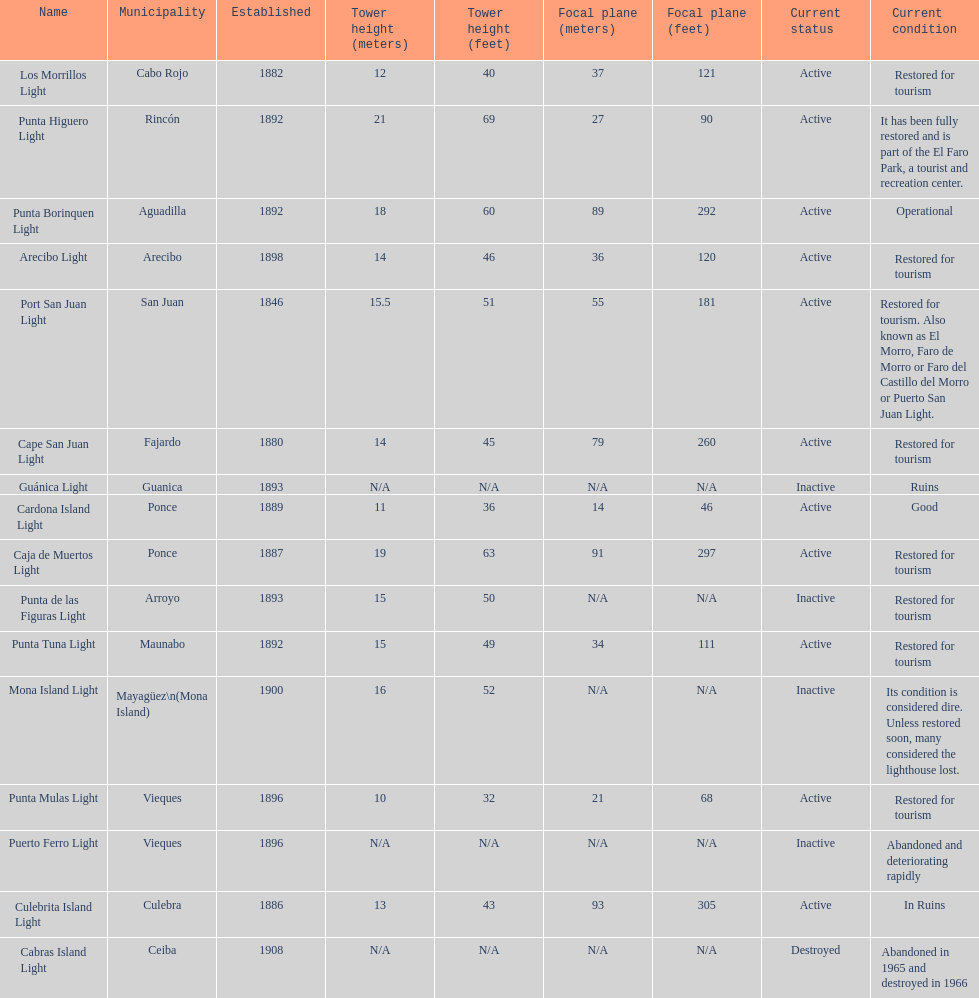Names of municipalities established before 1880 San Juan. Could you parse the entire table as a dict? {'header': ['Name', 'Municipality', 'Established', 'Tower height (meters)', 'Tower height (feet)', 'Focal plane (meters)', 'Focal plane (feet)', 'Current status', 'Current condition'], 'rows': [['Los Morrillos Light', 'Cabo Rojo', '1882', '12', '40', '37', '121', 'Active', 'Restored for tourism'], ['Punta Higuero Light', 'Rincón', '1892', '21', '69', '27', '90', 'Active', 'It has been fully restored and is part of the El Faro Park, a tourist and recreation center.'], ['Punta Borinquen Light', 'Aguadilla', '1892', '18', '60', '89', '292', 'Active', 'Operational'], ['Arecibo Light', 'Arecibo', '1898', '14', '46', '36', '120', 'Active', 'Restored for tourism'], ['Port San Juan Light', 'San Juan', '1846', '15.5', '51', '55', '181', 'Active', 'Restored for tourism. Also known as El Morro, Faro de Morro or Faro del Castillo del Morro or Puerto San Juan Light.'], ['Cape San Juan Light', 'Fajardo', '1880', '14', '45', '79', '260', 'Active', 'Restored for tourism'], ['Guánica Light', 'Guanica', '1893', 'N/A', 'N/A', 'N/A', 'N/A', 'Inactive', 'Ruins'], ['Cardona Island Light', 'Ponce', '1889', '11', '36', '14', '46', 'Active', 'Good'], ['Caja de Muertos Light', 'Ponce', '1887', '19', '63', '91', '297', 'Active', 'Restored for tourism'], ['Punta de las Figuras Light', 'Arroyo', '1893', '15', '50', 'N/A', 'N/A', 'Inactive', 'Restored for tourism'], ['Punta Tuna Light', 'Maunabo', '1892', '15', '49', '34', '111', 'Active', 'Restored for tourism'], ['Mona Island Light', 'Mayagüez\\n(Mona Island)', '1900', '16', '52', 'N/A', 'N/A', 'Inactive', 'Its condition is considered dire. Unless restored soon, many considered the lighthouse lost.'], ['Punta Mulas Light', 'Vieques', '1896', '10', '32', '21', '68', 'Active', 'Restored for tourism'], ['Puerto Ferro Light', 'Vieques', '1896', 'N/A', 'N/A', 'N/A', 'N/A', 'Inactive', 'Abandoned and deteriorating rapidly'], ['Culebrita Island Light', 'Culebra', '1886', '13', '43', '93', '305', 'Active', 'In Ruins'], ['Cabras Island Light', 'Ceiba', '1908', 'N/A', 'N/A', 'N/A', 'N/A', 'Destroyed', 'Abandoned in 1965 and destroyed in 1966']]} 